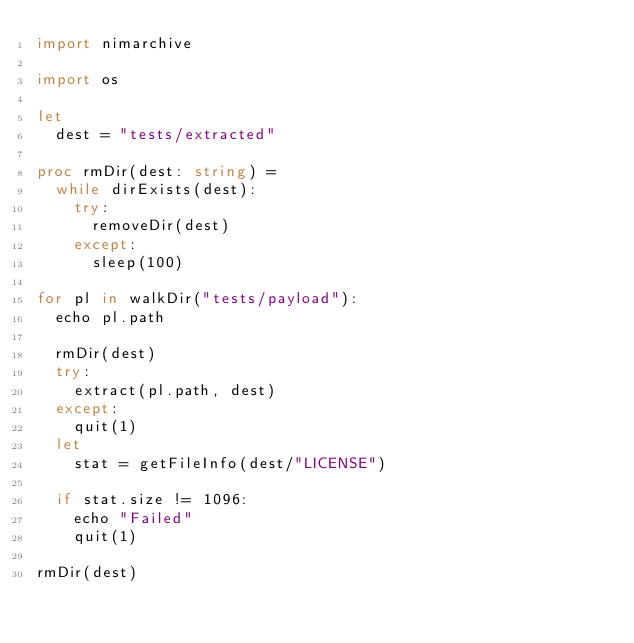Convert code to text. <code><loc_0><loc_0><loc_500><loc_500><_Nim_>import nimarchive

import os

let
  dest = "tests/extracted"

proc rmDir(dest: string) =
  while dirExists(dest):
    try:
      removeDir(dest)
    except:
      sleep(100)

for pl in walkDir("tests/payload"):
  echo pl.path

  rmDir(dest)
  try:
    extract(pl.path, dest)
  except:
    quit(1)
  let
    stat = getFileInfo(dest/"LICENSE")

  if stat.size != 1096:
    echo "Failed"
    quit(1)

rmDir(dest)
</code> 